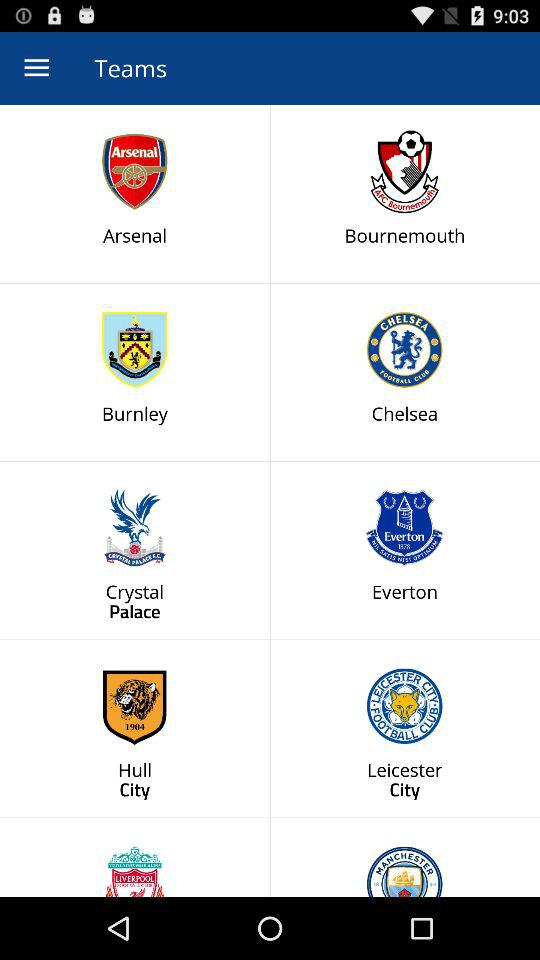What are the team names? The team names are "Arsenal", "Bournemouth", "Burnley", "Chelsea", "Crystal Palace", "Everton", "Hull City" and "Leicester City". 